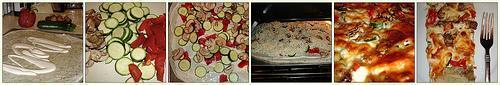How many prongs does the fork have?
Give a very brief answer. 4. 